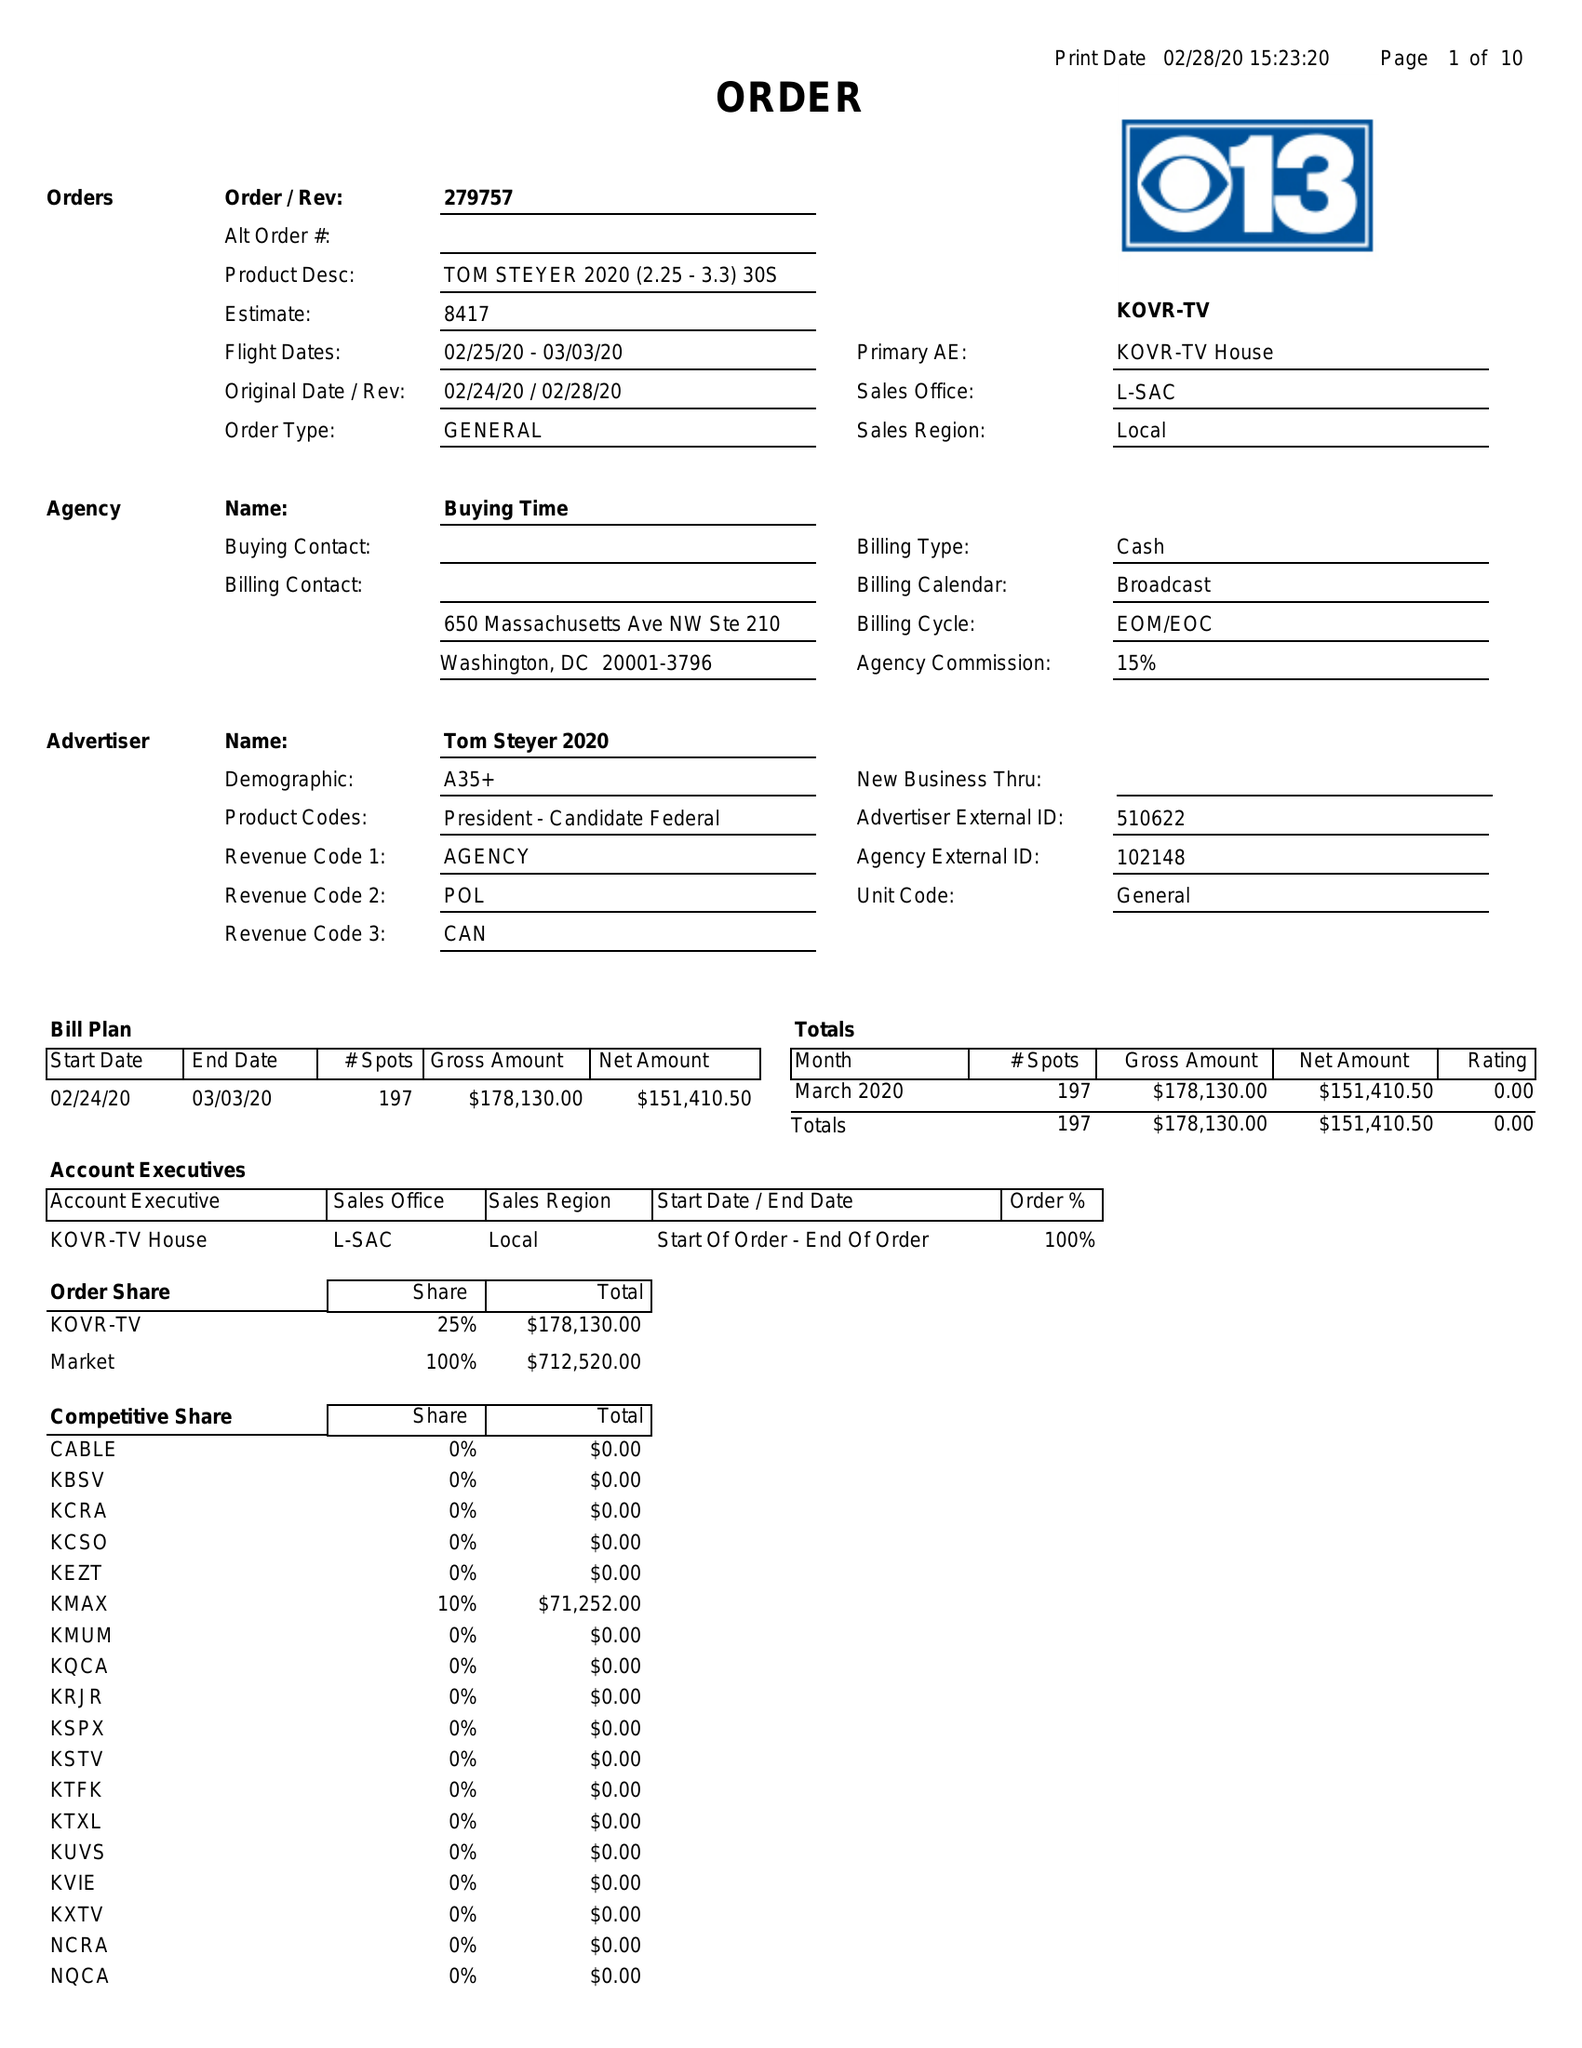What is the value for the flight_from?
Answer the question using a single word or phrase. 02/25/20 